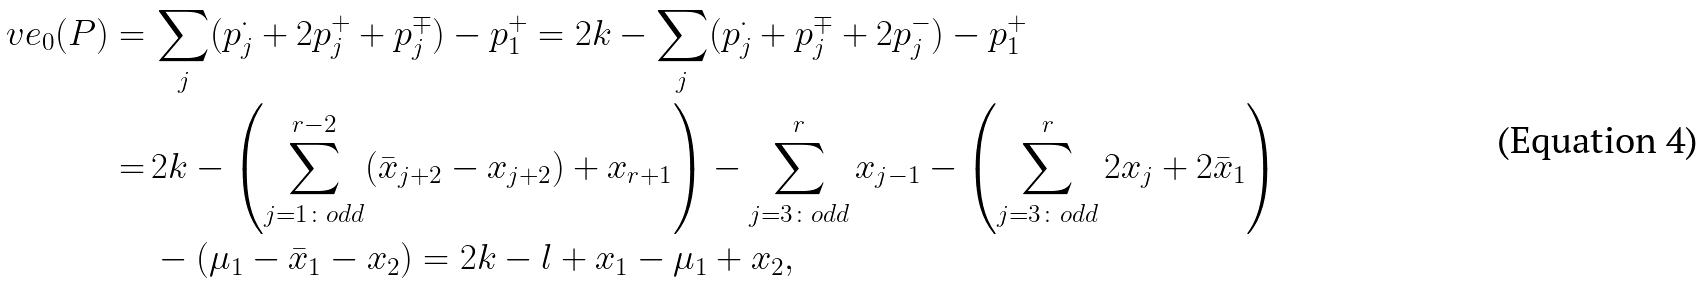<formula> <loc_0><loc_0><loc_500><loc_500>\ v e _ { 0 } ( P ) = & \, \sum _ { j } ( p _ { j } ^ { \cdot } + 2 p _ { j } ^ { + } + p _ { j } ^ { \mp } ) - p _ { 1 } ^ { + } = 2 k - \sum _ { j } ( p _ { j } ^ { \cdot } + p _ { j } ^ { \mp } + 2 p _ { j } ^ { - } ) - p _ { 1 } ^ { + } \\ = & \, 2 k - \left ( \sum _ { j = 1 \colon o d d } ^ { r - 2 } ( \bar { x } _ { j + 2 } - x _ { j + 2 } ) + x _ { r + 1 } \right ) - \sum _ { j = 3 \colon o d d } ^ { r } x _ { j - 1 } - \left ( \sum _ { j = 3 \colon o d d } ^ { r } 2 x _ { j } + 2 \bar { x } _ { 1 } \right ) \\ & \, - \left ( \mu _ { 1 } - \bar { x } _ { 1 } - x _ { 2 } \right ) = 2 k - l + x _ { 1 } - \mu _ { 1 } + x _ { 2 } ,</formula> 